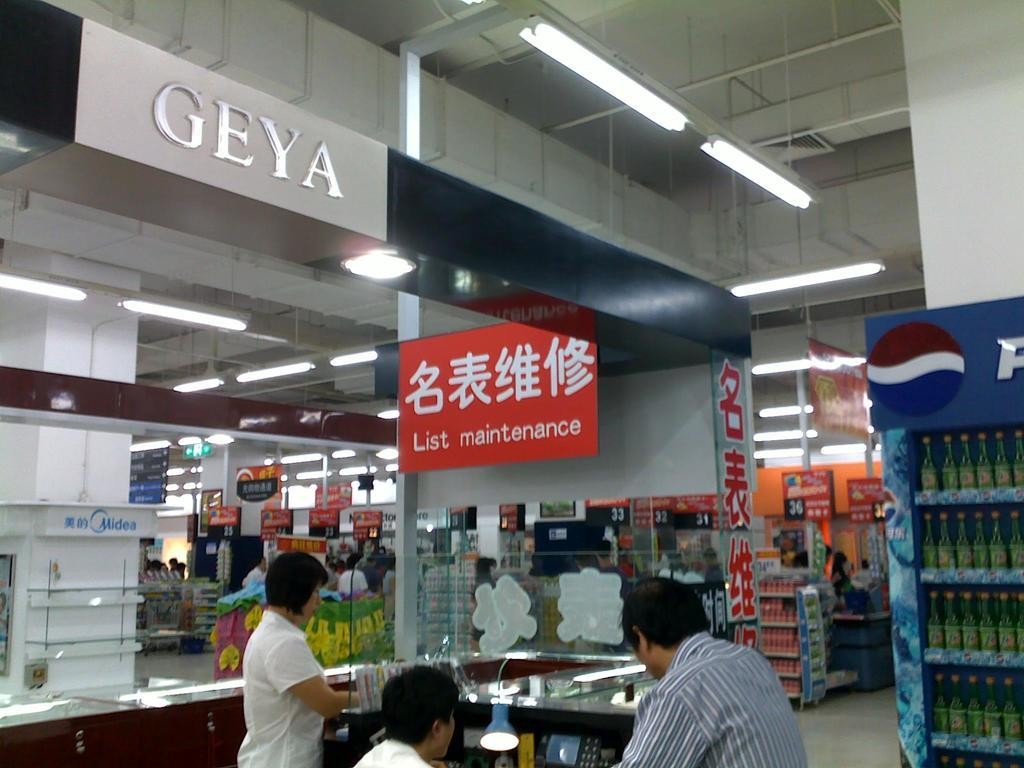<image>
Describe the image concisely. People in an area that is labeled list maintenance on a red sign. 